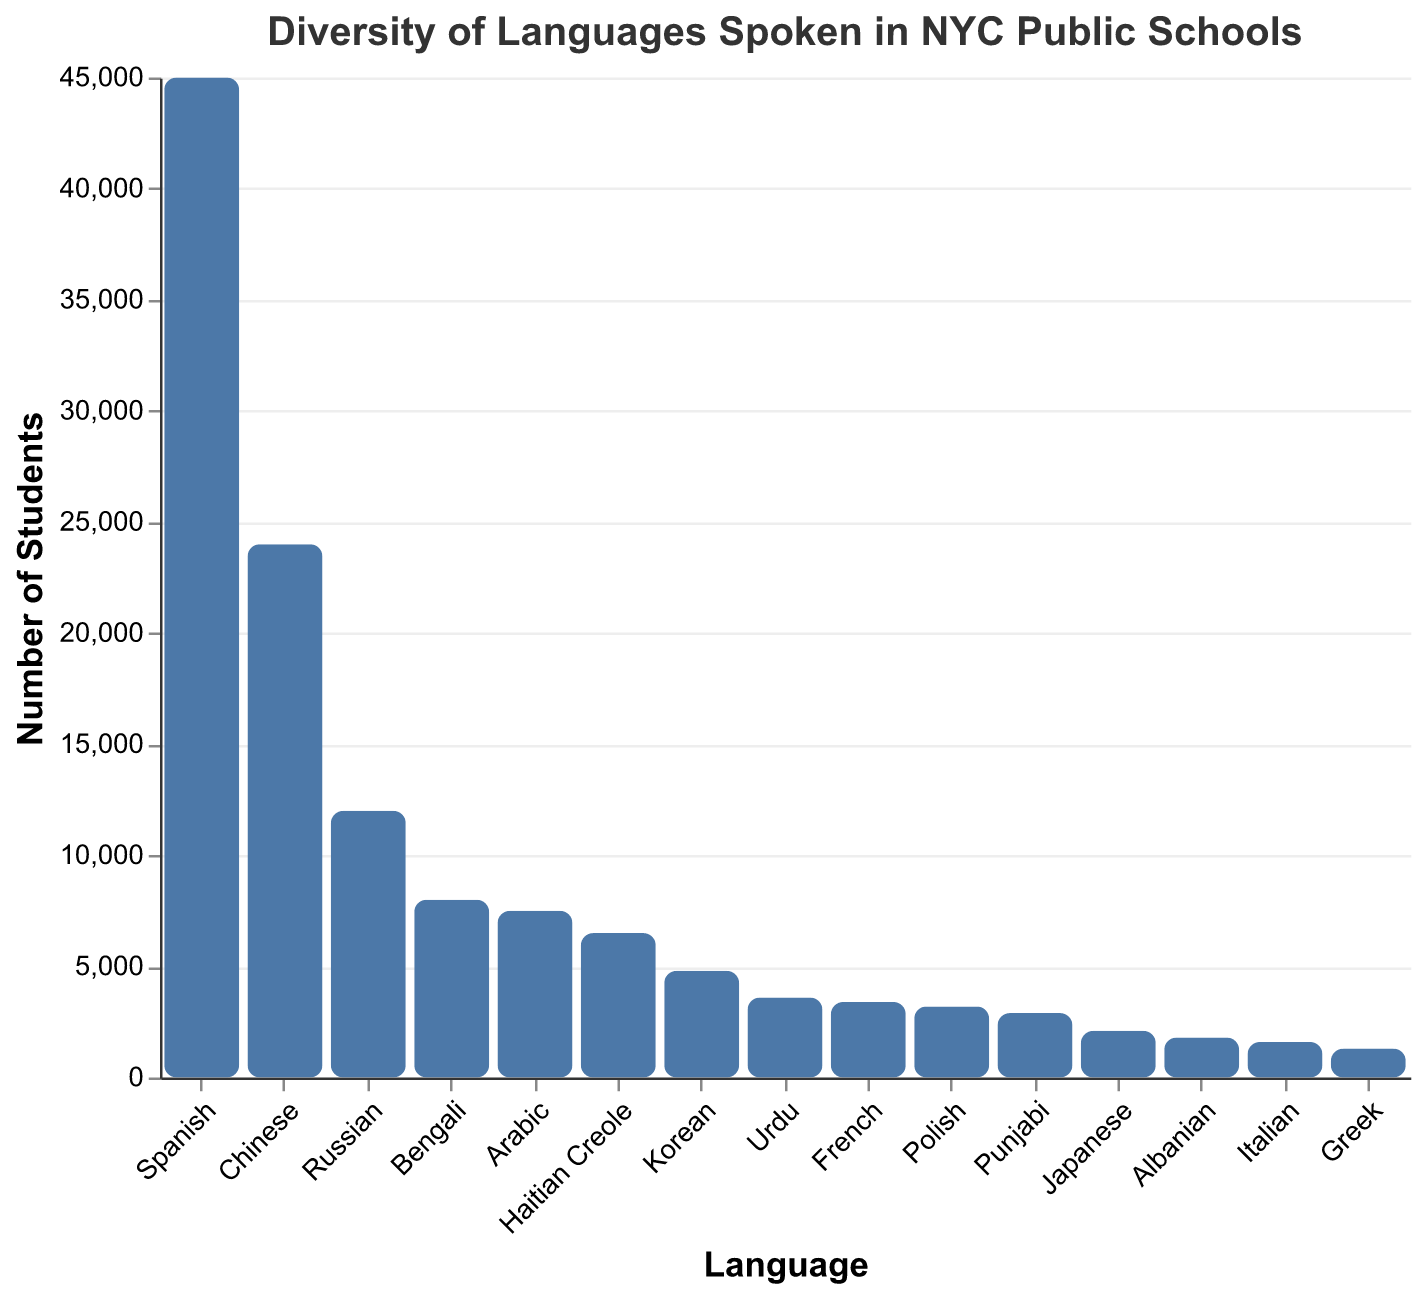Which language is spoken by the highest number of students? By examining the bars, it is evident that Spanish has the tallest bar, indicating the highest number of students.
Answer: Spanish How many students speak Chinese in NYC public schools? The tooltip or the bar corresponding to Chinese shows that there are 24,000 students.
Answer: 24,000 Which languages have fewer than 5,000 students each? By scanning the y-axis and bars, the languages with student numbers below 5,000 are Korean, Urdu, French, Polish, Punjabi, Japanese, Albanian, Italian, and Greek.
Answer: Korean, Urdu, French, Polish, Punjabi, Japanese, Albanian, Italian, Greek How many more students speak Spanish than Bengali? Subtract the number of Bengali-speaking students (8,000) from the number of Spanish-speaking students (45,000). (45,000 - 8,000 = 37,000)
Answer: 37,000 Between Arabic and Haitian Creole, which language has more students and by how much? Haitian Creole has 6,500 students while Arabic has 7,500 students. The difference is 7,500 - 6,500 = 1,000 students.
Answer: Arabic by 1,000 What is the total number of students speaking the top three most-spoken languages? The top three most-spoken languages are Spanish (45,000), Chinese (24,000), and Russian (12,000). Sum them up: 45,000 + 24,000 + 12,000 = 81,000
Answer: 81,000 What is the least spoken language among those listed? By examining the shortest bar, Greek, with 1,300 students, is identified as the least spoken language.
Answer: Greek How many students speak a language other than the top language? Subtract the number of Spanish-speaking students (45,000) from the total number of all students. Sum all student numbers: 45,000 + 24,000 + 12,000 + 8,000 + 7,500 + 6,500 + 4,800 + 3,600 + 3,400 + 3,200 + 2,900 + 2,100 + 1,800 + 1,600 + 1,300 = 127,700. Then, subtract Spanish: 127,700 - 45,000 = 82,700
Answer: 82,700 Which is more common: Urdu or French, and by how many students? French is spoken by 3,400 students, while Urdu is spoken by 3,600 students. The difference is 3,600 - 3,400 = 200 students.
Answer: Urdu by 200 What is the combined number of students speaking Bengali and Arabic? Add the number of Bengali-speaking students (8,000) to the number of Arabic-speaking students (7,500). (8,000 + 7,500 = 15,500)
Answer: 15,500 